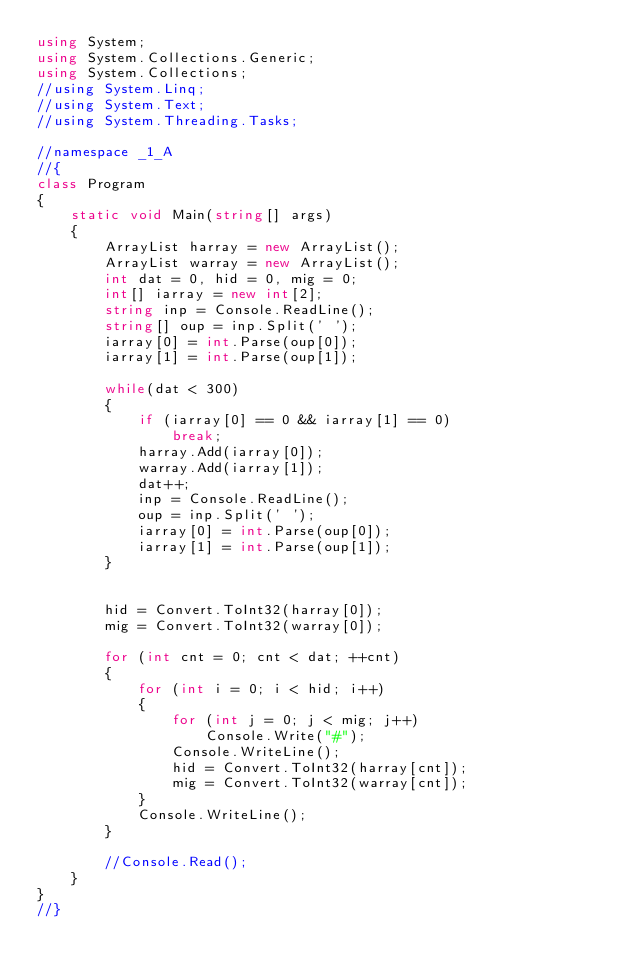<code> <loc_0><loc_0><loc_500><loc_500><_C#_>using System;
using System.Collections.Generic;
using System.Collections;
//using System.Linq;
//using System.Text;
//using System.Threading.Tasks;

//namespace _1_A
//{
class Program
{
    static void Main(string[] args)
    {
        ArrayList harray = new ArrayList();
        ArrayList warray = new ArrayList();
        int dat = 0, hid = 0, mig = 0;
        int[] iarray = new int[2];
        string inp = Console.ReadLine();
        string[] oup = inp.Split(' ');
        iarray[0] = int.Parse(oup[0]);
        iarray[1] = int.Parse(oup[1]);

        while(dat < 300)
        {
            if (iarray[0] == 0 && iarray[1] == 0)
                break;
            harray.Add(iarray[0]);
            warray.Add(iarray[1]);
            dat++;
            inp = Console.ReadLine();
            oup = inp.Split(' ');
            iarray[0] = int.Parse(oup[0]);
            iarray[1] = int.Parse(oup[1]);
        }


        hid = Convert.ToInt32(harray[0]);
        mig = Convert.ToInt32(warray[0]);

        for (int cnt = 0; cnt < dat; ++cnt)
        {
            for (int i = 0; i < hid; i++)
            {
                for (int j = 0; j < mig; j++)
                    Console.Write("#");
                Console.WriteLine();
                hid = Convert.ToInt32(harray[cnt]);
                mig = Convert.ToInt32(warray[cnt]);
            }
            Console.WriteLine();
        }

        //Console.Read();
    }
}
//}</code> 